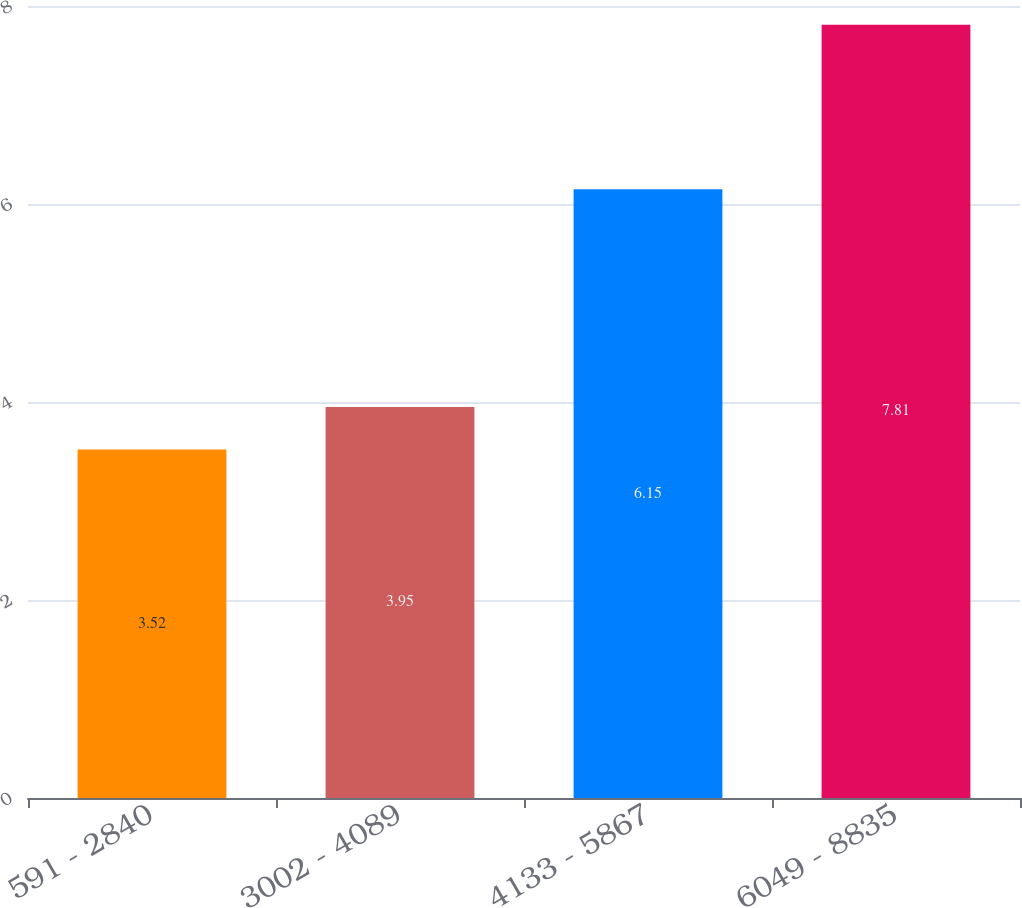Convert chart. <chart><loc_0><loc_0><loc_500><loc_500><bar_chart><fcel>591 - 2840<fcel>3002 - 4089<fcel>4133 - 5867<fcel>6049 - 8835<nl><fcel>3.52<fcel>3.95<fcel>6.15<fcel>7.81<nl></chart> 